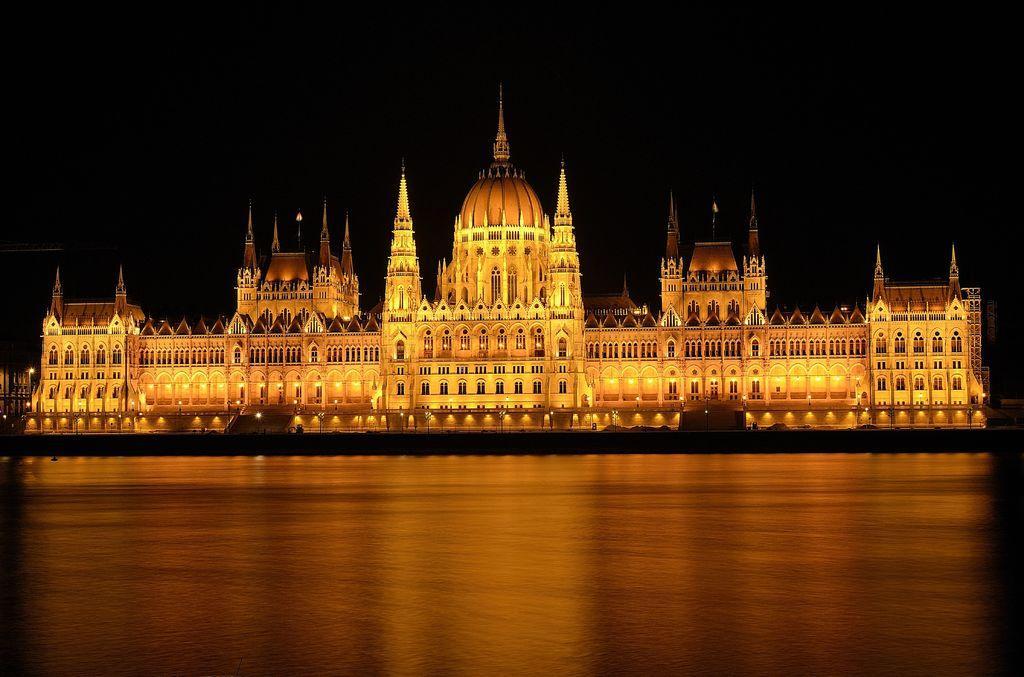Could you give a brief overview of what you see in this image? In this image in the center there is a palace and some lights, at the bottom there is walkway and there is a dark background. 